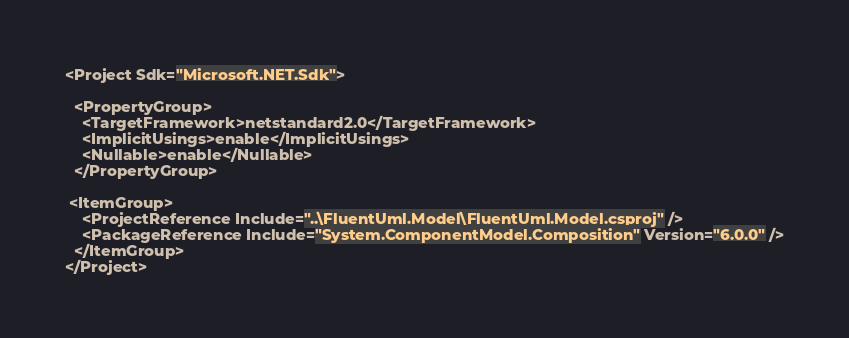Convert code to text. <code><loc_0><loc_0><loc_500><loc_500><_XML_><Project Sdk="Microsoft.NET.Sdk">

  <PropertyGroup>
    <TargetFramework>netstandard2.0</TargetFramework>
    <ImplicitUsings>enable</ImplicitUsings>
    <Nullable>enable</Nullable>
  </PropertyGroup>

 <ItemGroup>
    <ProjectReference Include="..\FluentUml.Model\FluentUml.Model.csproj" />
    <PackageReference Include="System.ComponentModel.Composition" Version="6.0.0" />
  </ItemGroup>
</Project>
</code> 